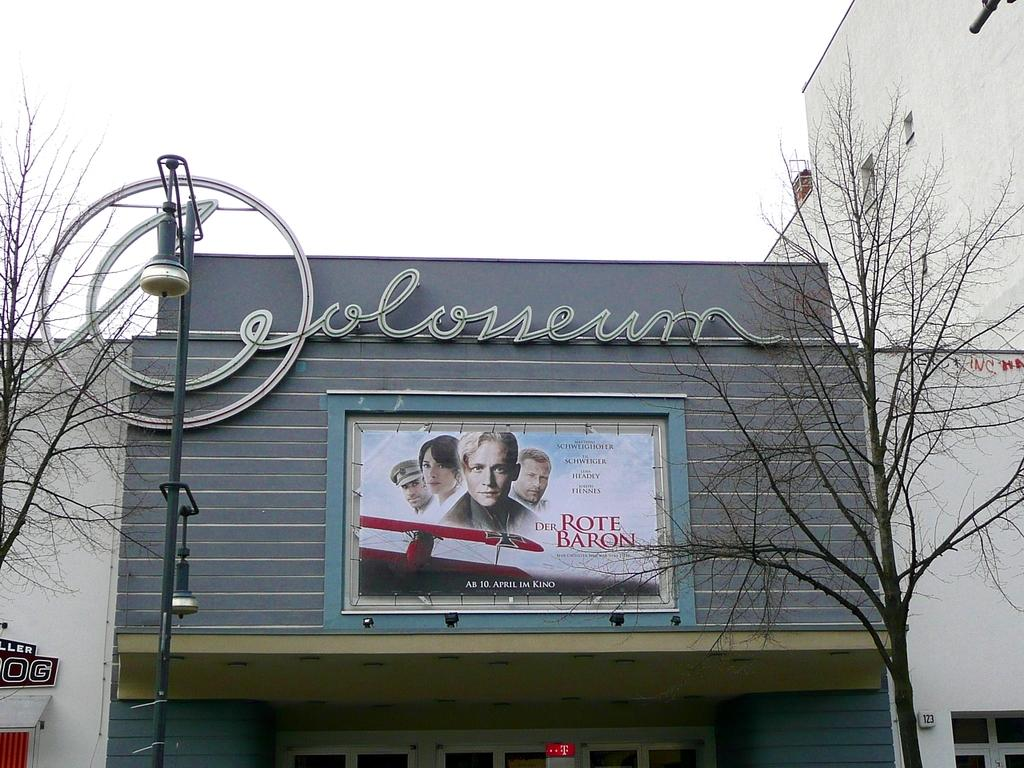<image>
Write a terse but informative summary of the picture. A picture of a theatre entrance with a poster advertising Der Rote Baron. 